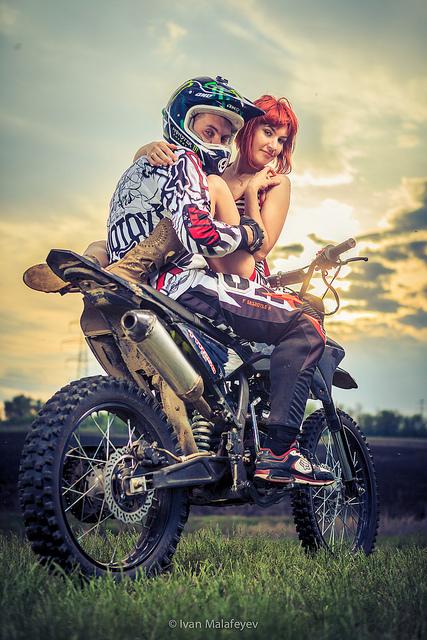Is this a grass track?
Keep it brief. No. Is the girl sitting properly on the bike?
Write a very short answer. No. Whose photography is this?
Write a very short answer. Ivan malafeyev. Are the bikers are in a race?
Write a very short answer. No. What does the watermark say at the bottom right corner?
Concise answer only. Ivan malafeyev. How many people are shown?
Answer briefly. 2. What is the bike designed for?
Answer briefly. Racing. What color are the bike rims?
Be succinct. Silver. 